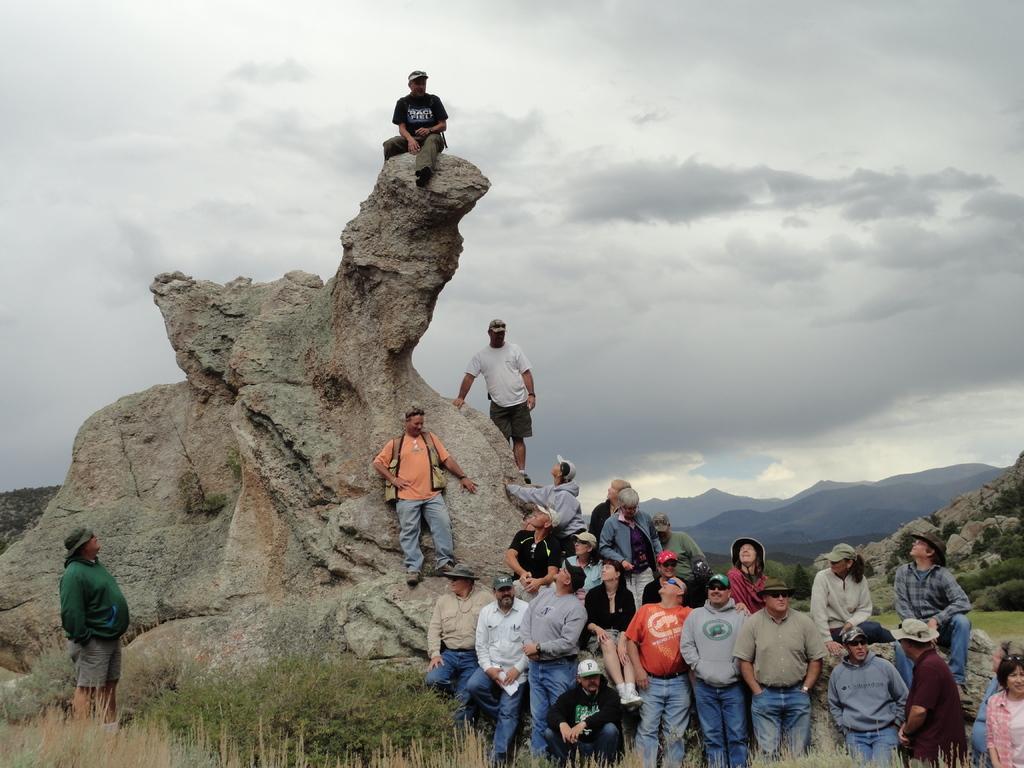In one or two sentences, can you explain what this image depicts? In this image, there are a few people, hills and rocks. We can see the ground. We can see some grass, plants. We can also see the sky with clouds. 